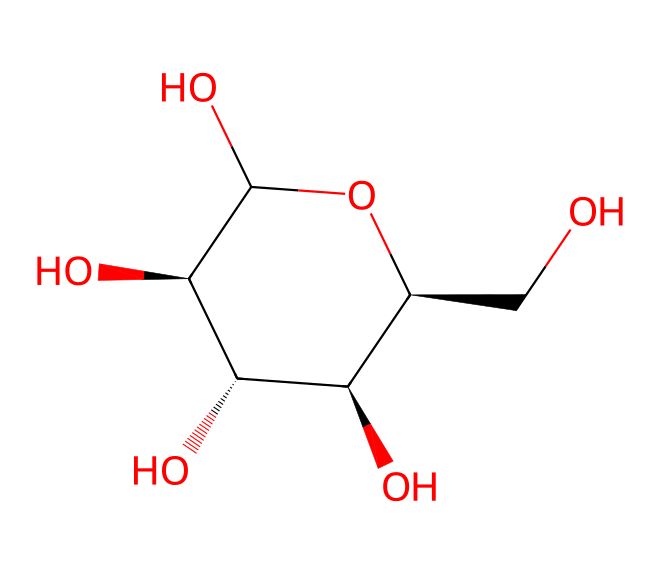How many carbon atoms are present in glucose? By analyzing the SMILES representation provided, we can count the 'C' symbols, which represent carbon atoms. In glucose, there are six 'C' occurrences.
Answer: six What is the molecular formula for glucose? To determine the molecular formula, we count the number of each type of atom represented in the SMILES: six carbon (C), twelve hydrogen (H), and six oxygen (O) atoms. Thus, the molecular formula is C6H12O6.
Answer: C6H12O6 How many hydroxyl (OH) groups are present in glucose? In the SMILES representation for glucose, we identify the -OH groups, which appear multiple times. Counting these, we find there are five hydroxyl groups.
Answer: five What type of carbohydrate is glucose? Glucose is a monosaccharide, which is a simple sugar that cannot be hydrolyzed into simpler sugars. It is also classified as an aldose due to the presence of an aldehyde group in its structure.
Answer: monosaccharide What structural feature indicates glucose is a cyclic compound? The notation within the SMILES representation contains the numbers (like '1' and '@'), which imply the formation of rings in chemical structures. This indicates glucose closes into a cyclic form, specifically a six-membered ring known as a pyranose.
Answer: cyclic How many asymmetric (chiral) centers does glucose have? In the structure of glucose, we can identify carbon atoms that have four different substituents attached to them. By analyzing the carbon atoms, we find there are four chiral centers in glucose.
Answer: four What is the significance of glucose in horse feed? Glucose serves as an essential carbohydrate source, providing energy necessary for racing performance and overall metabolic functions in horses. Its presence in horse feed is crucial for maintaining stamina and health.
Answer: energy source 